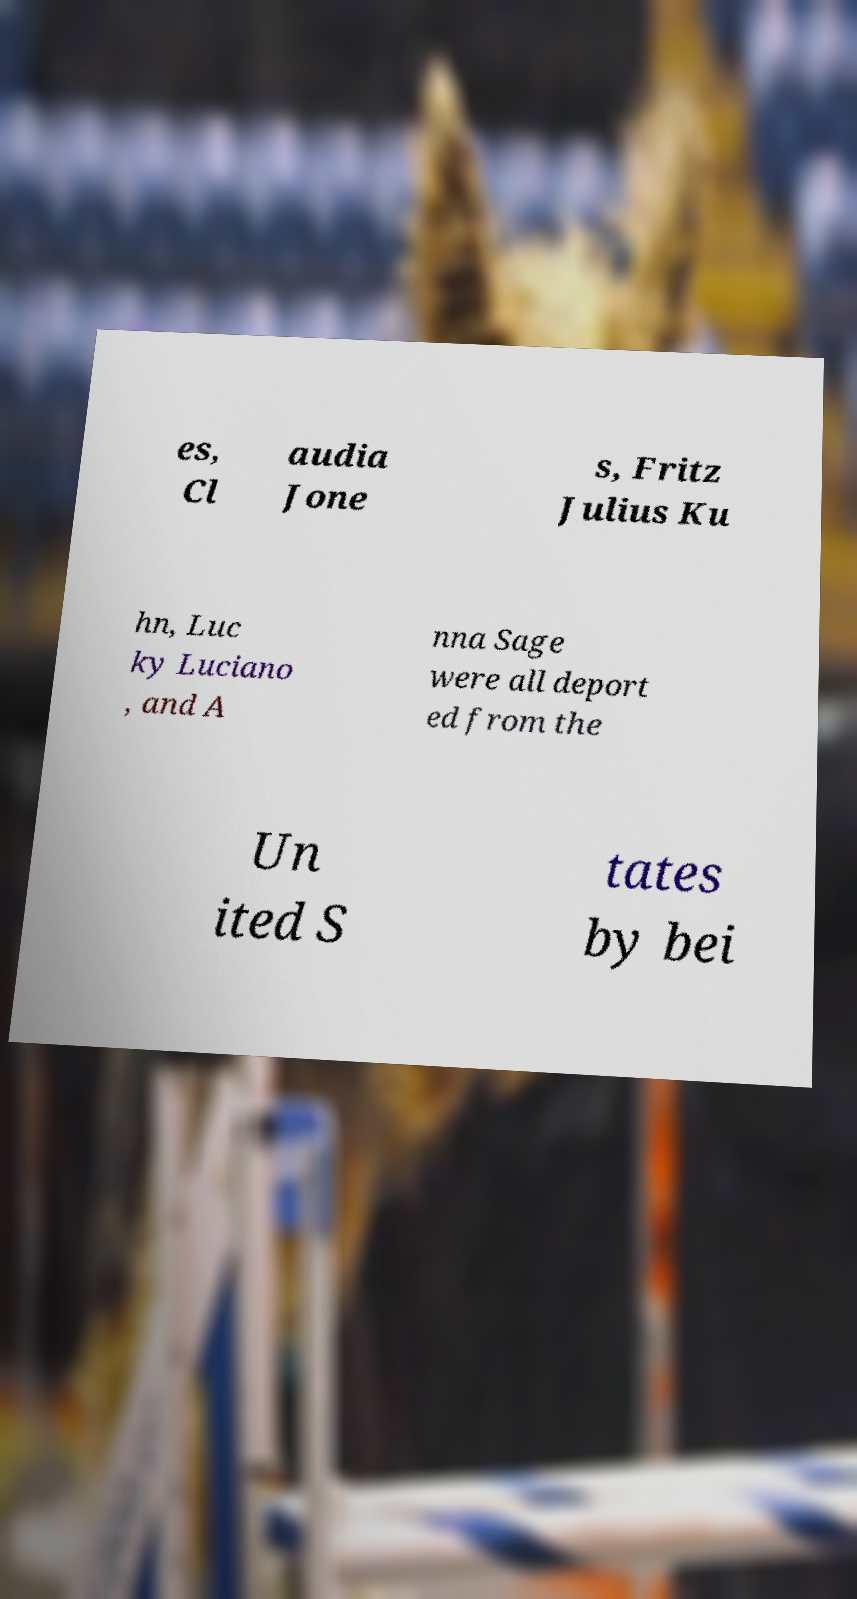For documentation purposes, I need the text within this image transcribed. Could you provide that? es, Cl audia Jone s, Fritz Julius Ku hn, Luc ky Luciano , and A nna Sage were all deport ed from the Un ited S tates by bei 